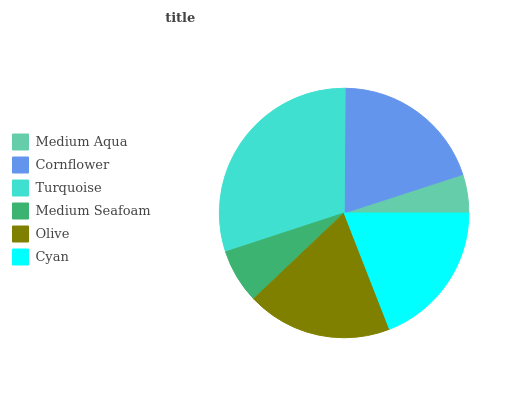Is Medium Aqua the minimum?
Answer yes or no. Yes. Is Turquoise the maximum?
Answer yes or no. Yes. Is Cornflower the minimum?
Answer yes or no. No. Is Cornflower the maximum?
Answer yes or no. No. Is Cornflower greater than Medium Aqua?
Answer yes or no. Yes. Is Medium Aqua less than Cornflower?
Answer yes or no. Yes. Is Medium Aqua greater than Cornflower?
Answer yes or no. No. Is Cornflower less than Medium Aqua?
Answer yes or no. No. Is Cyan the high median?
Answer yes or no. Yes. Is Olive the low median?
Answer yes or no. Yes. Is Turquoise the high median?
Answer yes or no. No. Is Medium Aqua the low median?
Answer yes or no. No. 